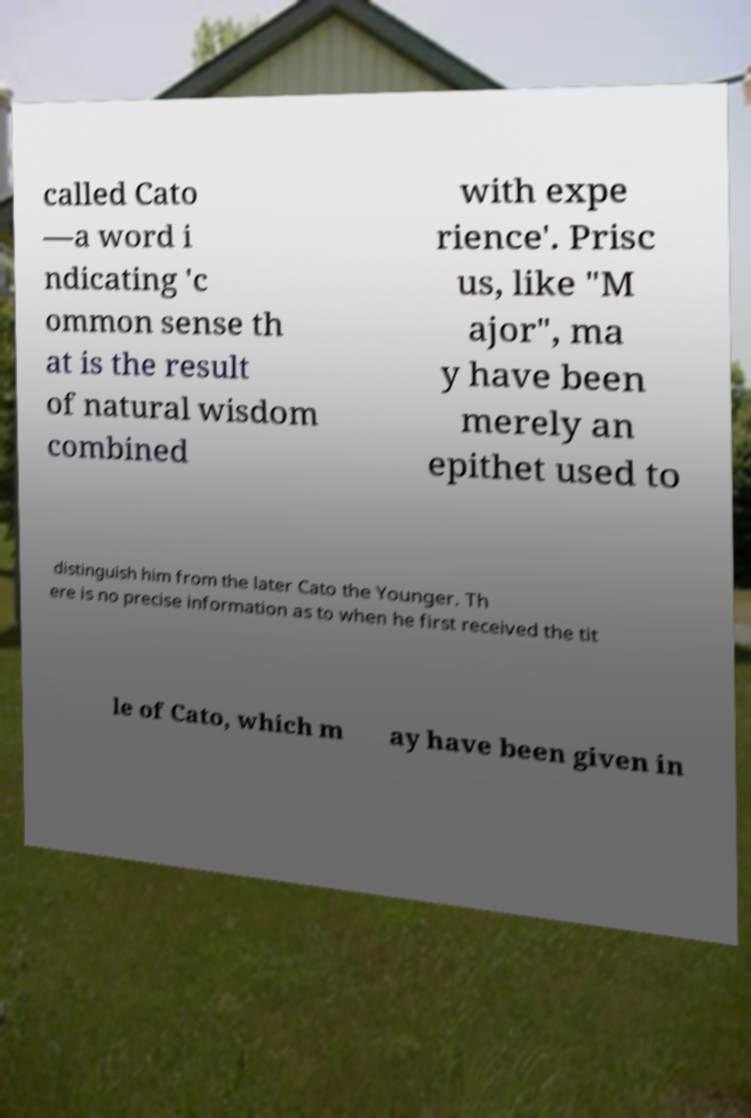For documentation purposes, I need the text within this image transcribed. Could you provide that? called Cato —a word i ndicating 'c ommon sense th at is the result of natural wisdom combined with expe rience'. Prisc us, like "M ajor", ma y have been merely an epithet used to distinguish him from the later Cato the Younger. Th ere is no precise information as to when he first received the tit le of Cato, which m ay have been given in 